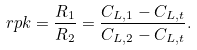<formula> <loc_0><loc_0><loc_500><loc_500>\ r p k = \frac { R _ { 1 } } { R _ { 2 } } = \frac { C _ { { \L L } , 1 } - C _ { { \L L } , t } } { C _ { { \L L } , 2 } - C _ { { \L L } , t } } .</formula> 